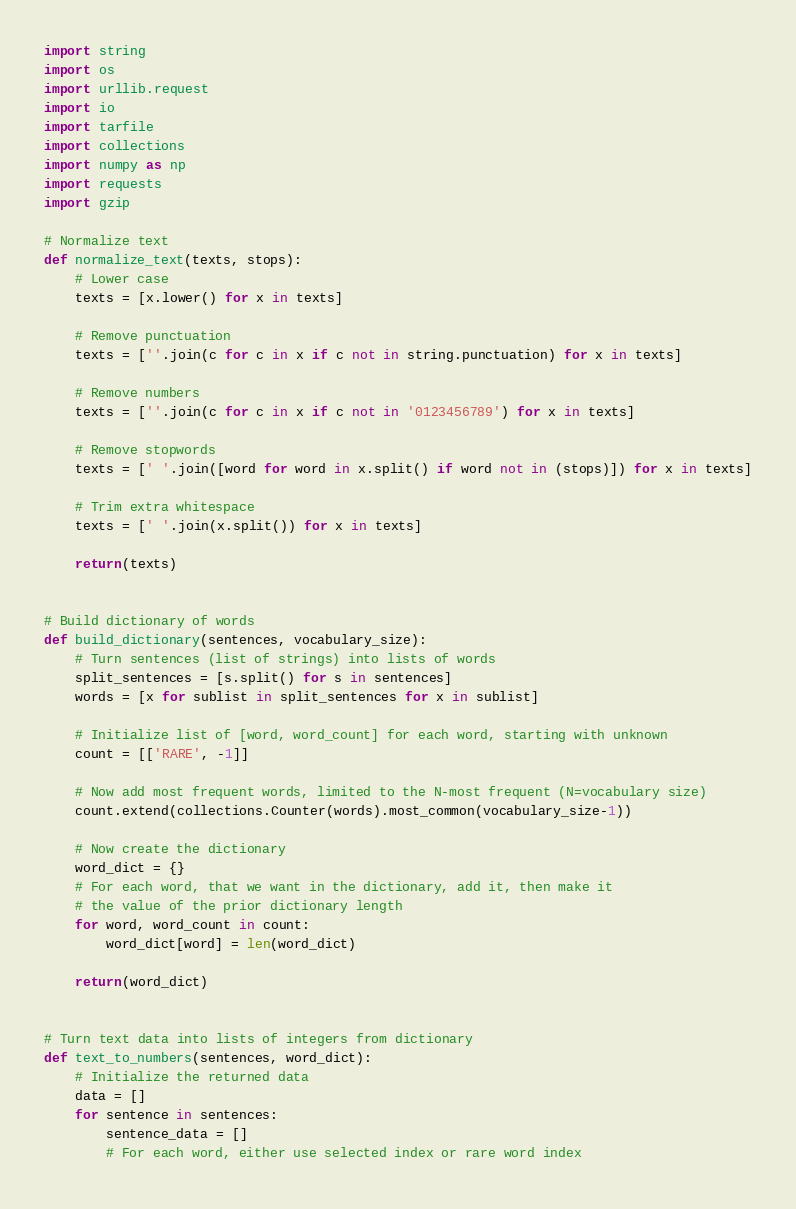Convert code to text. <code><loc_0><loc_0><loc_500><loc_500><_Python_>import string
import os
import urllib.request
import io
import tarfile
import collections
import numpy as np
import requests
import gzip

# Normalize text
def normalize_text(texts, stops):
    # Lower case
    texts = [x.lower() for x in texts]

    # Remove punctuation
    texts = [''.join(c for c in x if c not in string.punctuation) for x in texts]

    # Remove numbers
    texts = [''.join(c for c in x if c not in '0123456789') for x in texts]

    # Remove stopwords
    texts = [' '.join([word for word in x.split() if word not in (stops)]) for x in texts]

    # Trim extra whitespace
    texts = [' '.join(x.split()) for x in texts]

    return(texts)


# Build dictionary of words
def build_dictionary(sentences, vocabulary_size):
    # Turn sentences (list of strings) into lists of words
    split_sentences = [s.split() for s in sentences]
    words = [x for sublist in split_sentences for x in sublist]

    # Initialize list of [word, word_count] for each word, starting with unknown
    count = [['RARE', -1]]

    # Now add most frequent words, limited to the N-most frequent (N=vocabulary size)
    count.extend(collections.Counter(words).most_common(vocabulary_size-1))

    # Now create the dictionary
    word_dict = {}
    # For each word, that we want in the dictionary, add it, then make it
    # the value of the prior dictionary length
    for word, word_count in count:
        word_dict[word] = len(word_dict)

    return(word_dict)


# Turn text data into lists of integers from dictionary
def text_to_numbers(sentences, word_dict):
    # Initialize the returned data
    data = []
    for sentence in sentences:
        sentence_data = []
        # For each word, either use selected index or rare word index</code> 